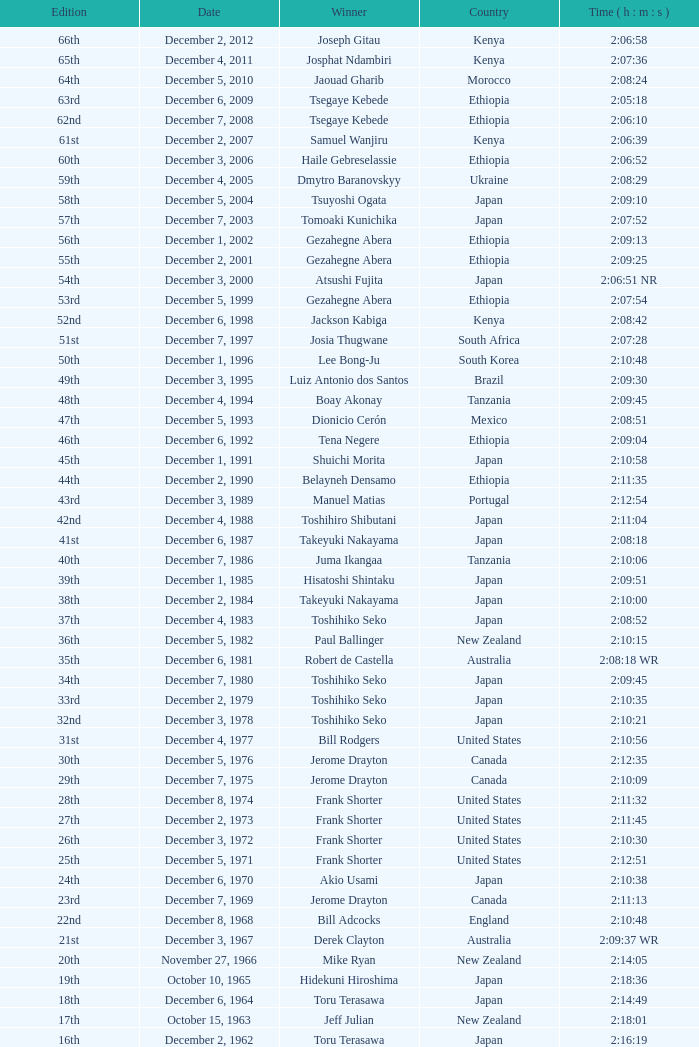What was the nationality of the winner on December 8, 1968? England. 